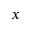<formula> <loc_0><loc_0><loc_500><loc_500>x</formula> 